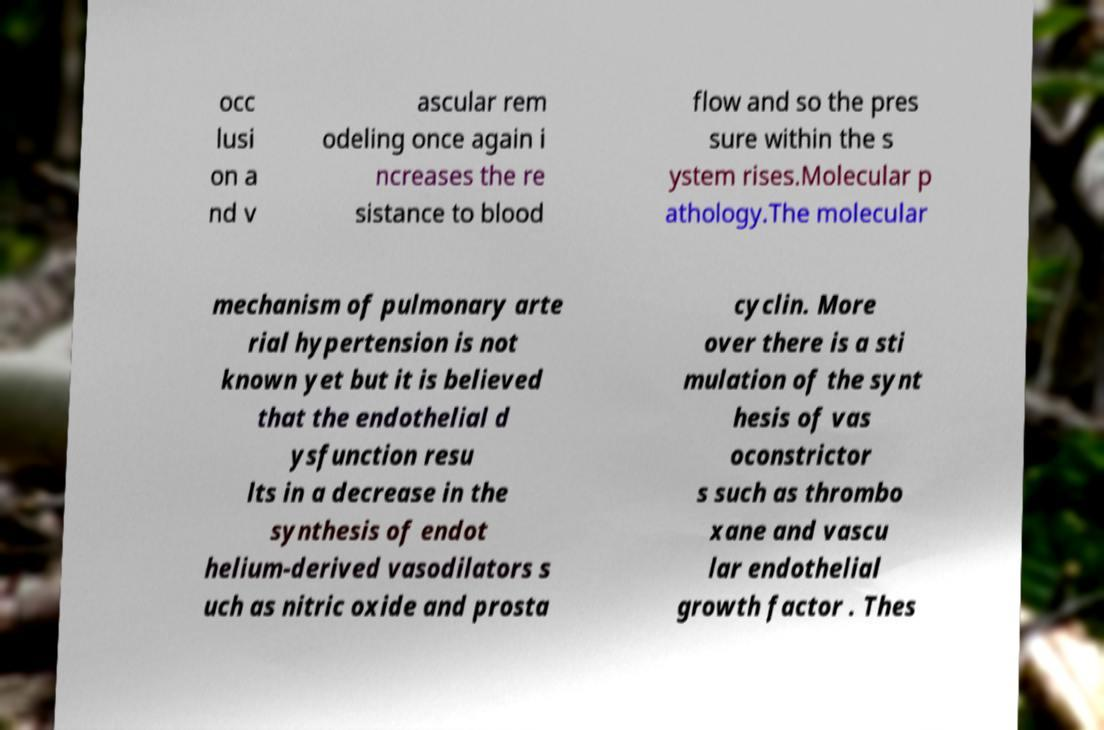What messages or text are displayed in this image? I need them in a readable, typed format. occ lusi on a nd v ascular rem odeling once again i ncreases the re sistance to blood flow and so the pres sure within the s ystem rises.Molecular p athology.The molecular mechanism of pulmonary arte rial hypertension is not known yet but it is believed that the endothelial d ysfunction resu lts in a decrease in the synthesis of endot helium-derived vasodilators s uch as nitric oxide and prosta cyclin. More over there is a sti mulation of the synt hesis of vas oconstrictor s such as thrombo xane and vascu lar endothelial growth factor . Thes 